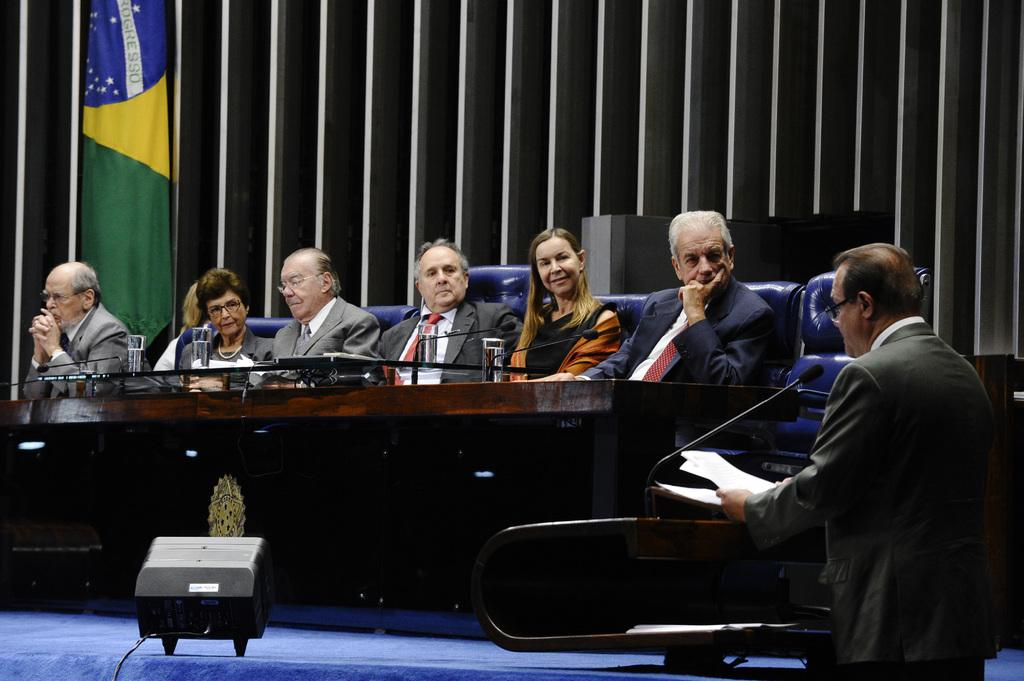What is the man in the image doing with his hand? The man is holding papers with his hand. What object is in front of the man? There is a microphone (mic) in front of the man. What are the people in the image doing? The people are sitting on chairs in the image. What can be seen on the table in the image? There are glasses on a table in the image. What is the flag used for in the image? The flag is present in the image, but its purpose is not clear from the facts provided. Can you describe any other objects present in the image? There are other objects present in the image, but their specific details are not mentioned in the facts provided. How many moons are visible in the image? There are no moons visible in the image. What type of eggnog is being served in the image? There is no eggnog present in the image. 